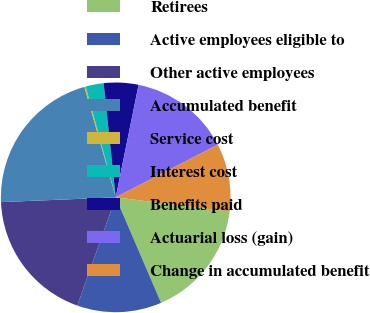Convert chart. <chart><loc_0><loc_0><loc_500><loc_500><pie_chart><fcel>Retirees<fcel>Active employees eligible to<fcel>Other active employees<fcel>Accumulated benefit<fcel>Service cost<fcel>Interest cost<fcel>Benefits paid<fcel>Actuarial loss (gain)<fcel>Change in accumulated benefit<nl><fcel>16.57%<fcel>11.89%<fcel>18.91%<fcel>21.26%<fcel>0.19%<fcel>2.53%<fcel>4.87%<fcel>14.23%<fcel>9.55%<nl></chart> 